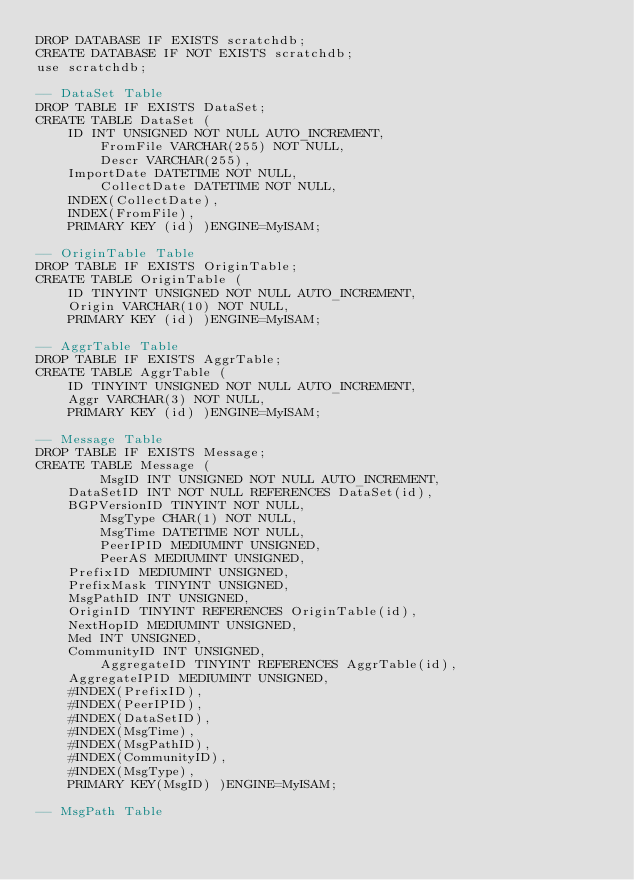<code> <loc_0><loc_0><loc_500><loc_500><_SQL_>DROP DATABASE IF EXISTS scratchdb;
CREATE DATABASE IF NOT EXISTS scratchdb;
use scratchdb;

-- DataSet Table
DROP TABLE IF EXISTS DataSet;
CREATE TABLE DataSet (
	ID INT UNSIGNED NOT NULL AUTO_INCREMENT,
        FromFile VARCHAR(255) NOT NULL,
        Descr VARCHAR(255),
	ImportDate DATETIME NOT NULL,
        CollectDate DATETIME NOT NULL,
	INDEX(CollectDate),	
	INDEX(FromFile),
	PRIMARY KEY (id) )ENGINE=MyISAM;

-- OriginTable Table
DROP TABLE IF EXISTS OriginTable;
CREATE TABLE OriginTable (
	ID TINYINT UNSIGNED NOT NULL AUTO_INCREMENT, 
	Origin VARCHAR(10) NOT NULL,
	PRIMARY KEY (id) )ENGINE=MyISAM;

-- AggrTable Table
DROP TABLE IF EXISTS AggrTable;
CREATE TABLE AggrTable (
	ID TINYINT UNSIGNED NOT NULL AUTO_INCREMENT,
	Aggr VARCHAR(3) NOT NULL,
	PRIMARY KEY (id) )ENGINE=MyISAM;

-- Message Table
DROP TABLE IF EXISTS Message; 
CREATE TABLE Message ( 
        MsgID INT UNSIGNED NOT NULL AUTO_INCREMENT,
	DataSetID INT NOT NULL REFERENCES DataSet(id), 
	BGPVersionID TINYINT NOT NULL,
        MsgType CHAR(1) NOT NULL,
        MsgTime DATETIME NOT NULL,
        PeerIPID MEDIUMINT UNSIGNED,
        PeerAS MEDIUMINT UNSIGNED,
	PrefixID MEDIUMINT UNSIGNED,
	PrefixMask TINYINT UNSIGNED,
	MsgPathID INT UNSIGNED,
	OriginID TINYINT REFERENCES OriginTable(id),
	NextHopID MEDIUMINT UNSIGNED,
	Med INT UNSIGNED,
	CommunityID INT UNSIGNED,
        AggregateID TINYINT REFERENCES AggrTable(id),
 	AggregateIPID MEDIUMINT UNSIGNED,
	#INDEX(PrefixID),
	#INDEX(PeerIPID),
	#INDEX(DataSetID),
	#INDEX(MsgTime),
	#INDEX(MsgPathID),
	#INDEX(CommunityID),
	#INDEX(MsgType),
	PRIMARY KEY(MsgID) )ENGINE=MyISAM;

-- MsgPath Table</code> 